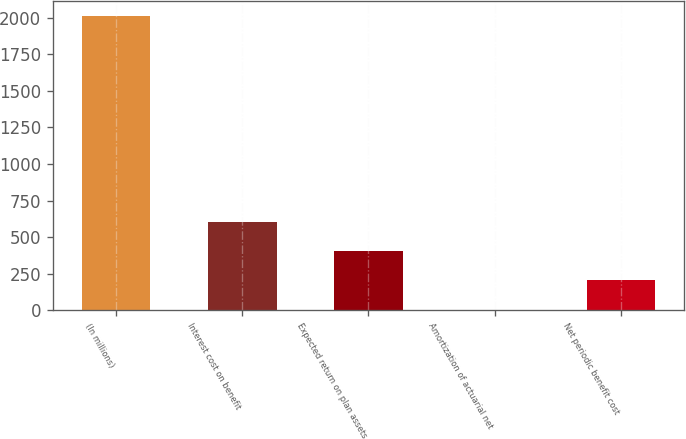Convert chart to OTSL. <chart><loc_0><loc_0><loc_500><loc_500><bar_chart><fcel>(In millions)<fcel>Interest cost on benefit<fcel>Expected return on plan assets<fcel>Amortization of actuarial net<fcel>Net periodic benefit cost<nl><fcel>2012<fcel>605.91<fcel>405.04<fcel>3.3<fcel>204.17<nl></chart> 